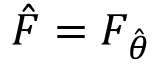Convert formula to latex. <formula><loc_0><loc_0><loc_500><loc_500>{ \hat { F } } = F _ { \hat { \theta } }</formula> 